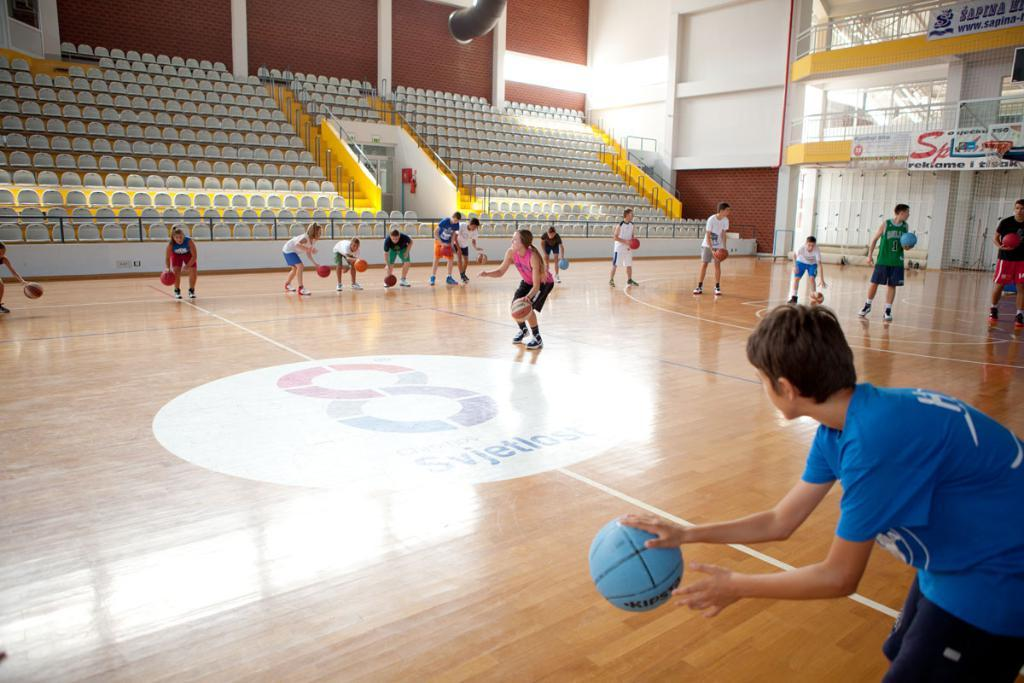Provide a one-sentence caption for the provided image. A player in a green jersey with the number 1 on it plays with his classmates in gym. 